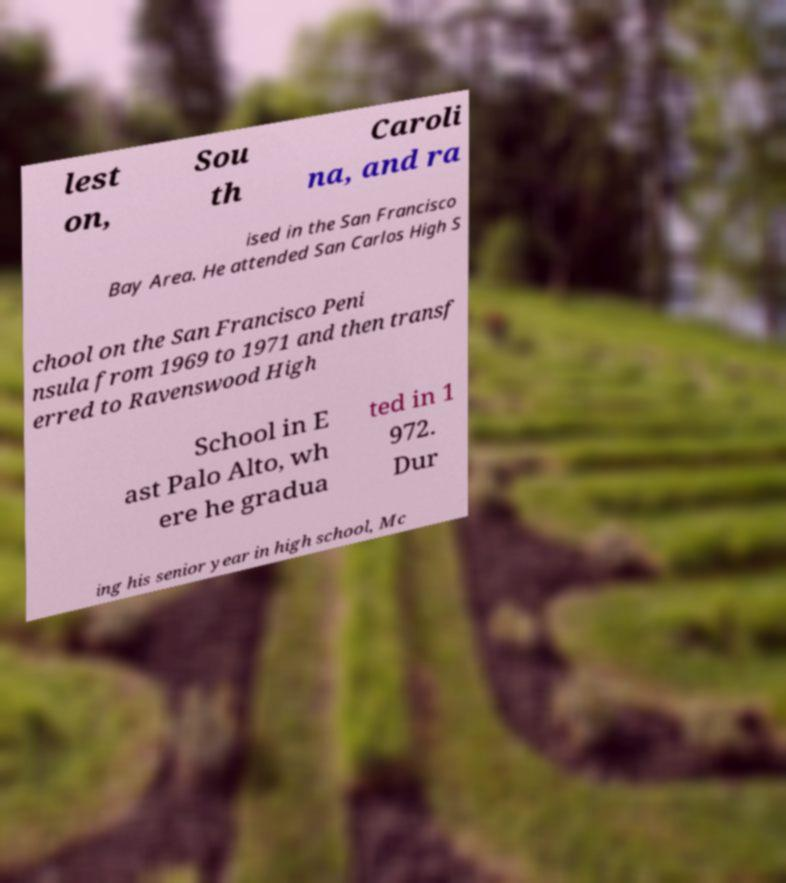Could you assist in decoding the text presented in this image and type it out clearly? lest on, Sou th Caroli na, and ra ised in the San Francisco Bay Area. He attended San Carlos High S chool on the San Francisco Peni nsula from 1969 to 1971 and then transf erred to Ravenswood High School in E ast Palo Alto, wh ere he gradua ted in 1 972. Dur ing his senior year in high school, Mc 